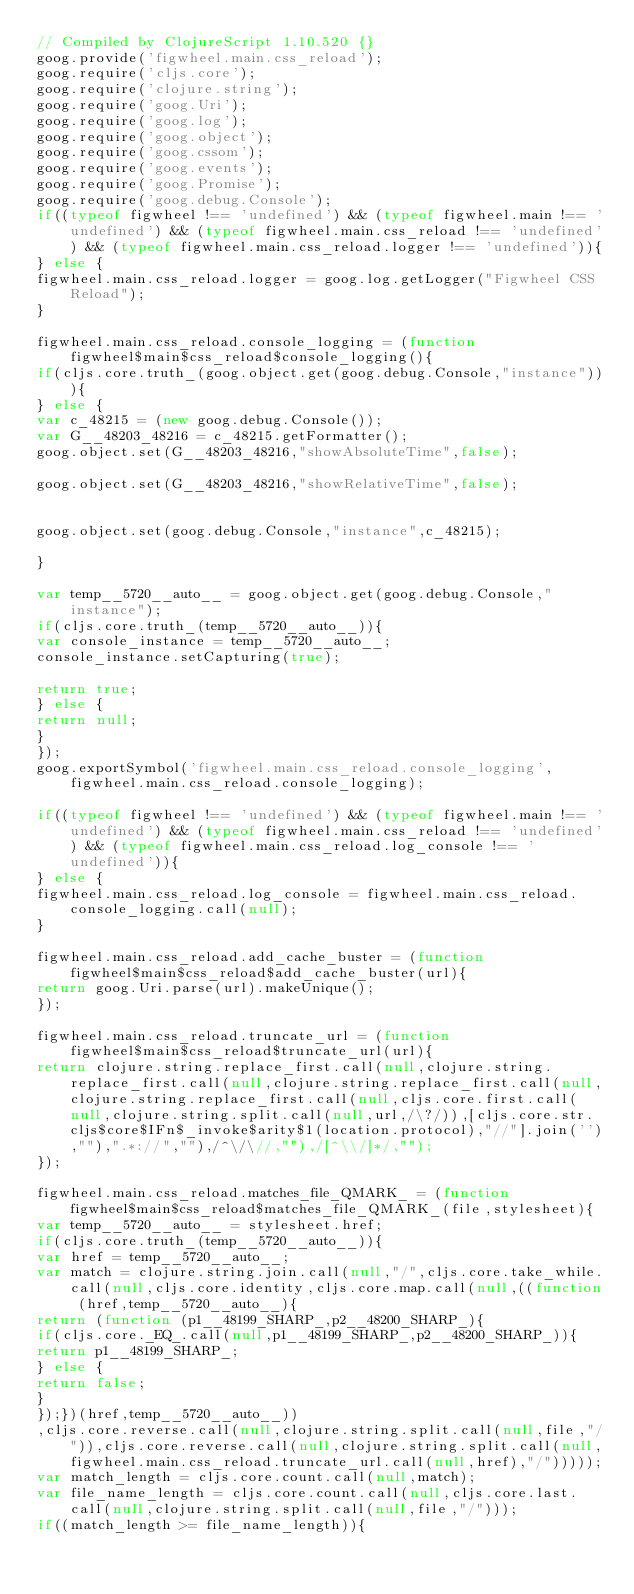<code> <loc_0><loc_0><loc_500><loc_500><_JavaScript_>// Compiled by ClojureScript 1.10.520 {}
goog.provide('figwheel.main.css_reload');
goog.require('cljs.core');
goog.require('clojure.string');
goog.require('goog.Uri');
goog.require('goog.log');
goog.require('goog.object');
goog.require('goog.cssom');
goog.require('goog.events');
goog.require('goog.Promise');
goog.require('goog.debug.Console');
if((typeof figwheel !== 'undefined') && (typeof figwheel.main !== 'undefined') && (typeof figwheel.main.css_reload !== 'undefined') && (typeof figwheel.main.css_reload.logger !== 'undefined')){
} else {
figwheel.main.css_reload.logger = goog.log.getLogger("Figwheel CSS Reload");
}

figwheel.main.css_reload.console_logging = (function figwheel$main$css_reload$console_logging(){
if(cljs.core.truth_(goog.object.get(goog.debug.Console,"instance"))){
} else {
var c_48215 = (new goog.debug.Console());
var G__48203_48216 = c_48215.getFormatter();
goog.object.set(G__48203_48216,"showAbsoluteTime",false);

goog.object.set(G__48203_48216,"showRelativeTime",false);


goog.object.set(goog.debug.Console,"instance",c_48215);

}

var temp__5720__auto__ = goog.object.get(goog.debug.Console,"instance");
if(cljs.core.truth_(temp__5720__auto__)){
var console_instance = temp__5720__auto__;
console_instance.setCapturing(true);

return true;
} else {
return null;
}
});
goog.exportSymbol('figwheel.main.css_reload.console_logging', figwheel.main.css_reload.console_logging);

if((typeof figwheel !== 'undefined') && (typeof figwheel.main !== 'undefined') && (typeof figwheel.main.css_reload !== 'undefined') && (typeof figwheel.main.css_reload.log_console !== 'undefined')){
} else {
figwheel.main.css_reload.log_console = figwheel.main.css_reload.console_logging.call(null);
}

figwheel.main.css_reload.add_cache_buster = (function figwheel$main$css_reload$add_cache_buster(url){
return goog.Uri.parse(url).makeUnique();
});

figwheel.main.css_reload.truncate_url = (function figwheel$main$css_reload$truncate_url(url){
return clojure.string.replace_first.call(null,clojure.string.replace_first.call(null,clojure.string.replace_first.call(null,clojure.string.replace_first.call(null,cljs.core.first.call(null,clojure.string.split.call(null,url,/\?/)),[cljs.core.str.cljs$core$IFn$_invoke$arity$1(location.protocol),"//"].join(''),""),".*://",""),/^\/\//,""),/[^\\/]*/,"");
});

figwheel.main.css_reload.matches_file_QMARK_ = (function figwheel$main$css_reload$matches_file_QMARK_(file,stylesheet){
var temp__5720__auto__ = stylesheet.href;
if(cljs.core.truth_(temp__5720__auto__)){
var href = temp__5720__auto__;
var match = clojure.string.join.call(null,"/",cljs.core.take_while.call(null,cljs.core.identity,cljs.core.map.call(null,((function (href,temp__5720__auto__){
return (function (p1__48199_SHARP_,p2__48200_SHARP_){
if(cljs.core._EQ_.call(null,p1__48199_SHARP_,p2__48200_SHARP_)){
return p1__48199_SHARP_;
} else {
return false;
}
});})(href,temp__5720__auto__))
,cljs.core.reverse.call(null,clojure.string.split.call(null,file,"/")),cljs.core.reverse.call(null,clojure.string.split.call(null,figwheel.main.css_reload.truncate_url.call(null,href),"/")))));
var match_length = cljs.core.count.call(null,match);
var file_name_length = cljs.core.count.call(null,cljs.core.last.call(null,clojure.string.split.call(null,file,"/")));
if((match_length >= file_name_length)){</code> 